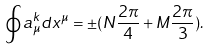<formula> <loc_0><loc_0><loc_500><loc_500>\oint a ^ { k } _ { \mu } d x ^ { \mu } = \pm ( N \frac { 2 \pi } { 4 } + M \frac { 2 \pi } { 3 } ) .</formula> 